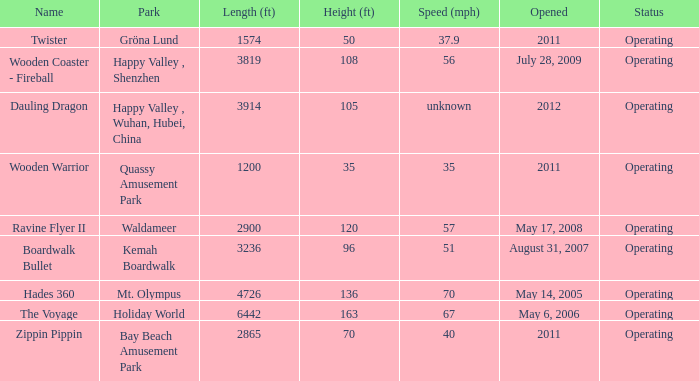How fast is the coaster that is 163 feet tall 67.0. 